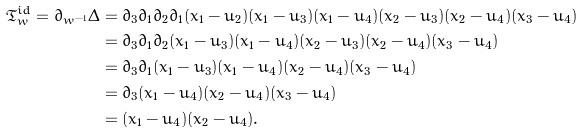Convert formula to latex. <formula><loc_0><loc_0><loc_500><loc_500>\mathfrak { T } _ { w } ^ { i d } = \partial _ { w ^ { - 1 } } \Delta & = \partial _ { 3 } \partial _ { 1 } \partial _ { 2 } \partial _ { 1 } ( x _ { 1 } - u _ { 2 } ) ( x _ { 1 } - u _ { 3 } ) ( x _ { 1 } - u _ { 4 } ) ( x _ { 2 } - u _ { 3 } ) ( x _ { 2 } - u _ { 4 } ) ( x _ { 3 } - u _ { 4 } ) \\ & = \partial _ { 3 } \partial _ { 1 } \partial _ { 2 } ( x _ { 1 } - u _ { 3 } ) ( x _ { 1 } - u _ { 4 } ) ( x _ { 2 } - u _ { 3 } ) ( x _ { 2 } - u _ { 4 } ) ( x _ { 3 } - u _ { 4 } ) \\ & = \partial _ { 3 } \partial _ { 1 } ( x _ { 1 } - u _ { 3 } ) ( x _ { 1 } - u _ { 4 } ) ( x _ { 2 } - u _ { 4 } ) ( x _ { 3 } - u _ { 4 } ) \\ & = \partial _ { 3 } ( x _ { 1 } - u _ { 4 } ) ( x _ { 2 } - u _ { 4 } ) ( x _ { 3 } - u _ { 4 } ) \\ & = ( x _ { 1 } - u _ { 4 } ) ( x _ { 2 } - u _ { 4 } ) .</formula> 